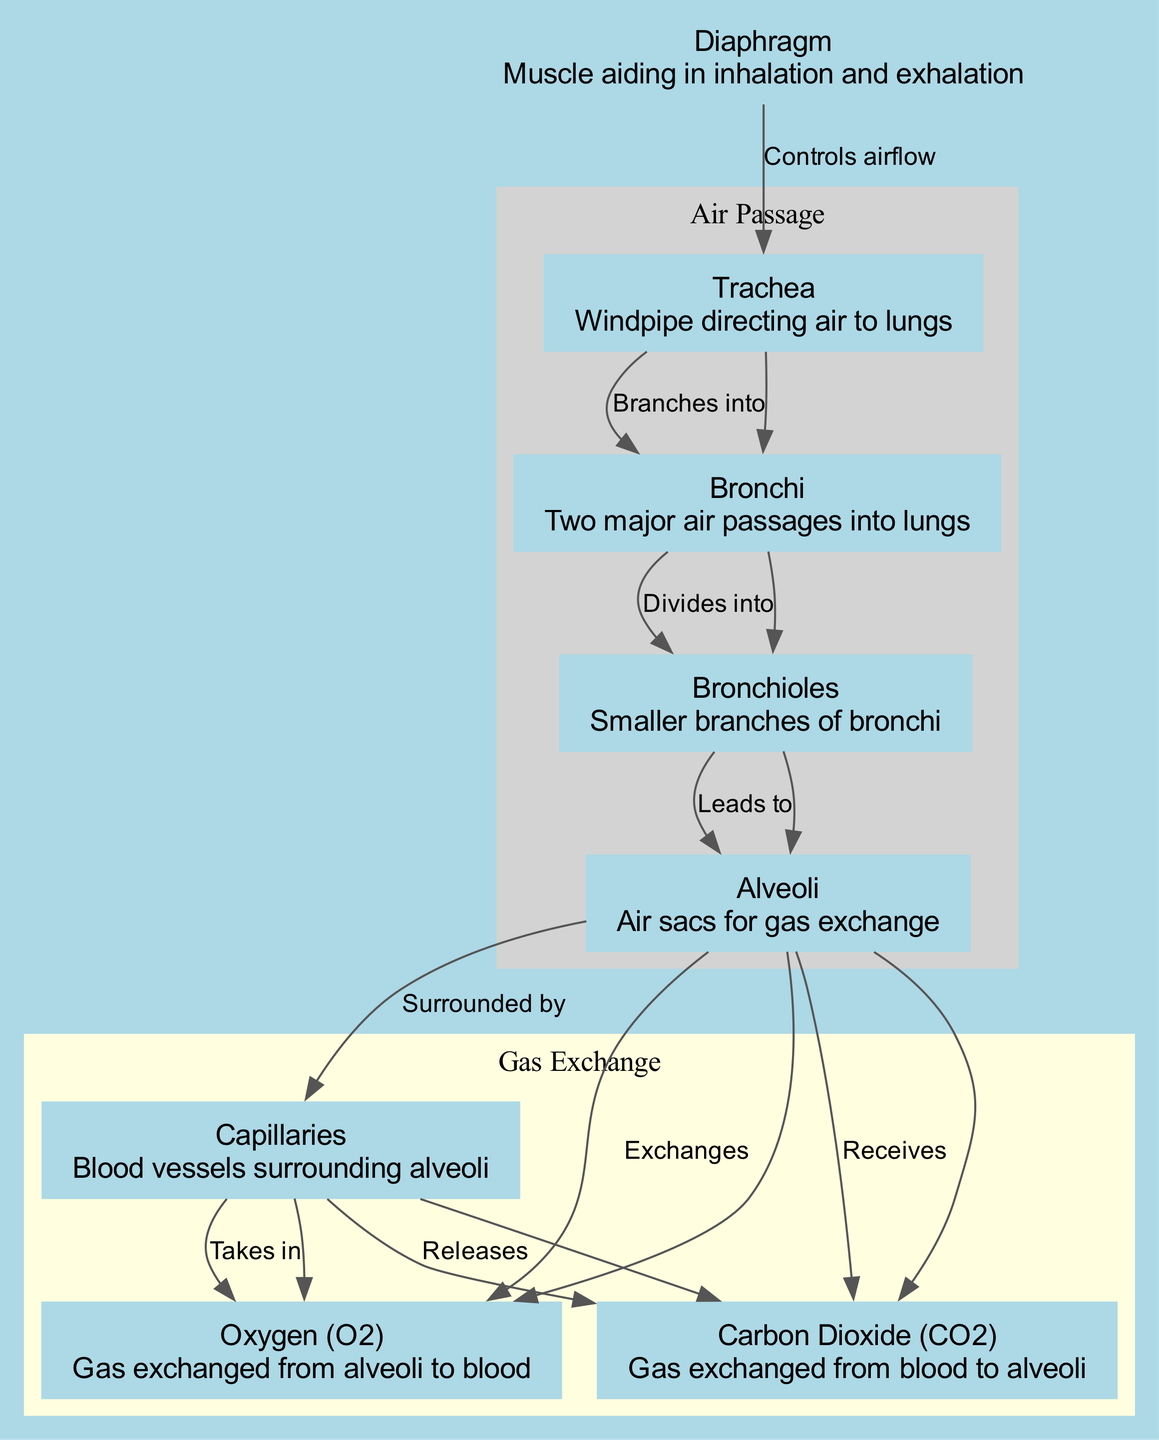What is the starting point for air entering the lungs? The diagram indicates that air begins its journey through the trachea, which is labeled and described as the windpipe directing air to the lungs. Therefore, the starting point is clear.
Answer: Trachea How many major air passages are there into the lungs? According to the diagram, the bronchi represent the two major air passages that branch from the trachea, which is indicated in the connections labeled as "Branches into". Thus, there are two major air passages.
Answer: Two What is the final destination of air in the respiratory system? The diagram shows that the airflow leads from the bronchioles to the alveoli. The alveoli are where gas exchange occurs, thus they represent the final destination of air in the respiratory system.
Answer: Alveoli What surrounds the alveoli to facilitate gas exchange? The diagram clearly illustrates that capillaries surround the alveoli. This is indicated by the connection labeled "Surrounded by". Therefore, capillaries play a crucial role by being the blood vessels that encircle the alveoli.
Answer: Capillaries What gas is exchanged from the alveoli to the blood? The arrows in the diagram show a direction from the alveoli to the capillaries with the label "Exchanges". The gas that moves from the alveoli into the bloodstream is oxygen, as indicated in the node description.
Answer: Oxygen (O2) What role does the diaphragm play in respiration? The diagram details that the diaphragm controls airflow into the trachea, indicating its importance in the process of inhalation and exhalation. This shows that the diaphragm is essential for effective breathing.
Answer: Controls airflow How does carbon dioxide move in the respiratory system? The diagram outlines that carbon dioxide travels from the capillaries to the alveoli, as shown by the edge labeled "Releases". This indicates that carbon dioxide, a waste gas in respiration, is expelled from the blood into the alveoli.
Answer: Releases What is the pathway of airflow from the trachea to the alveoli? Analyzing the connections, the flow of air first goes from the trachea to the bronchi, then divides into the bronchioles, and finally leads to the alveoli. Thus, the pathway of airflow is trachea ➔ bronchi ➔ bronchioles ➔ alveoli.
Answer: Trachea ➔ bronchi ➔ bronchioles ➔ alveoli How do capillaries interact with oxygen in the respiratory process? The diagram indicates that capillaries take in oxygen from the alveoli as specified by the label "Takes in", which highlights the critical role capillaries play in oxygen transportation from the lungs to the bloodstream.
Answer: Takes in 